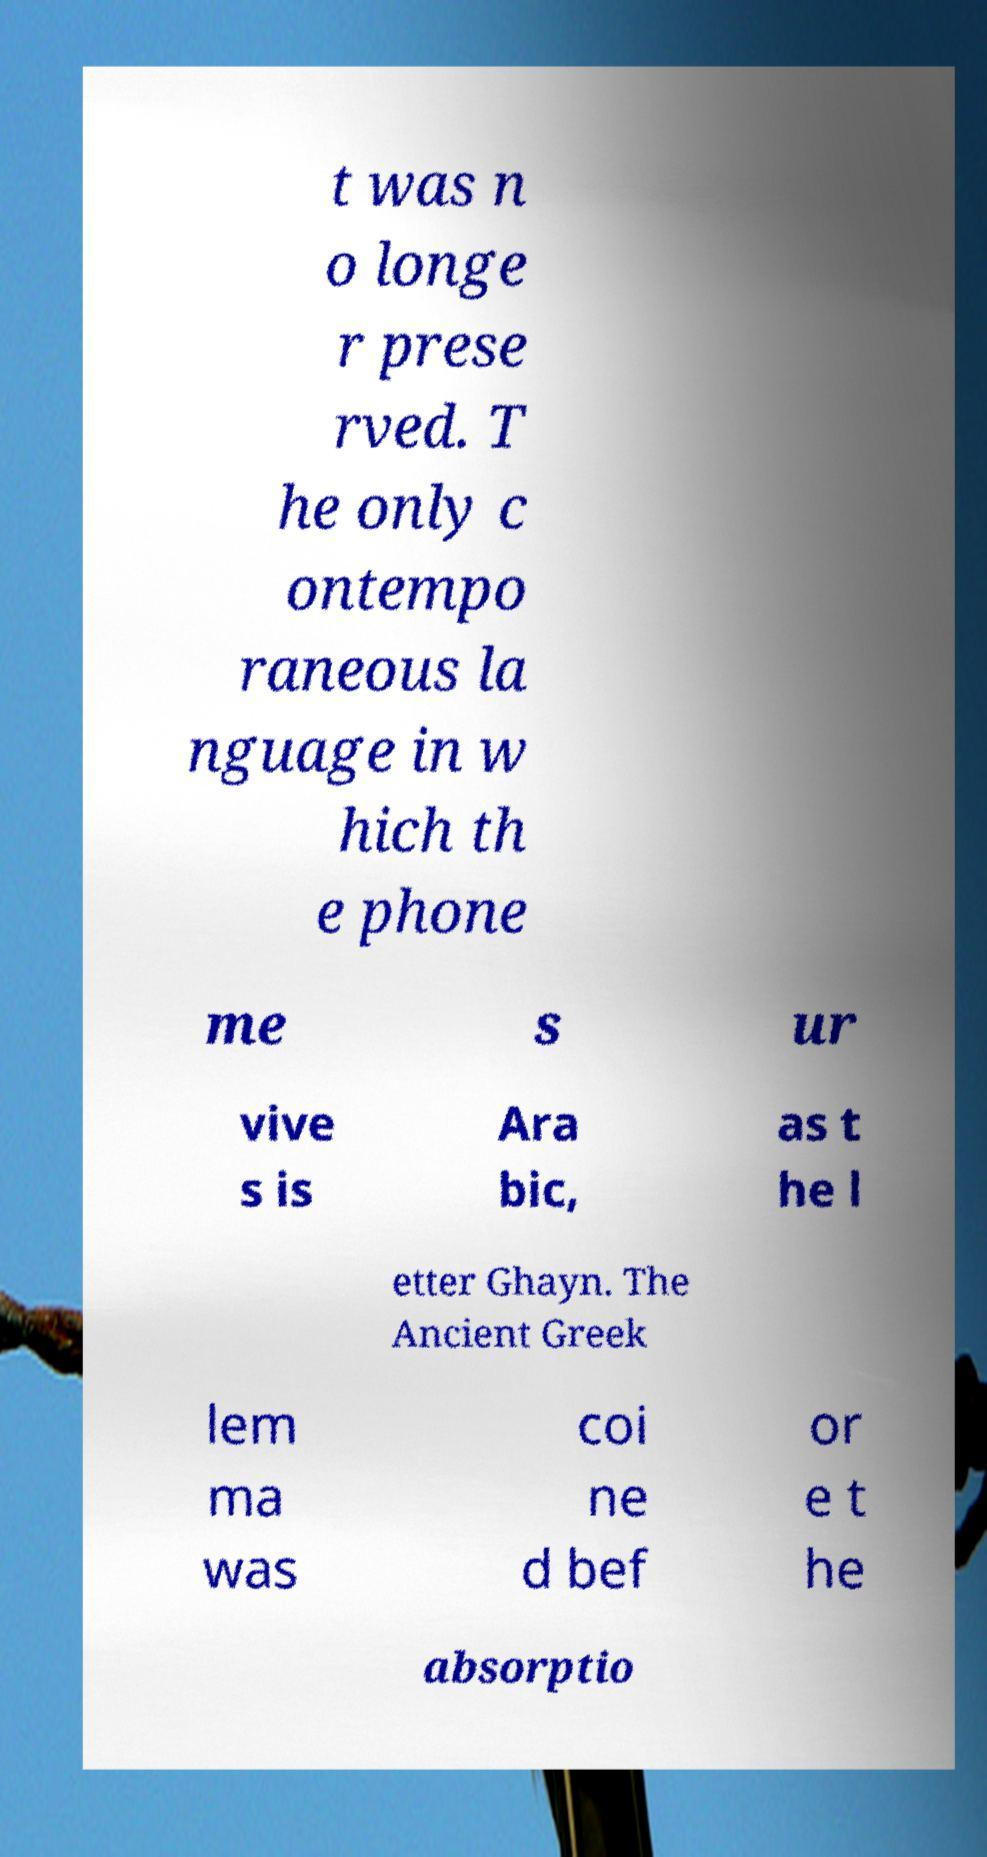For documentation purposes, I need the text within this image transcribed. Could you provide that? t was n o longe r prese rved. T he only c ontempo raneous la nguage in w hich th e phone me s ur vive s is Ara bic, as t he l etter Ghayn. The Ancient Greek lem ma was coi ne d bef or e t he absorptio 